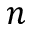Convert formula to latex. <formula><loc_0><loc_0><loc_500><loc_500>n</formula> 